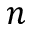Convert formula to latex. <formula><loc_0><loc_0><loc_500><loc_500>n</formula> 